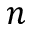Convert formula to latex. <formula><loc_0><loc_0><loc_500><loc_500>n</formula> 